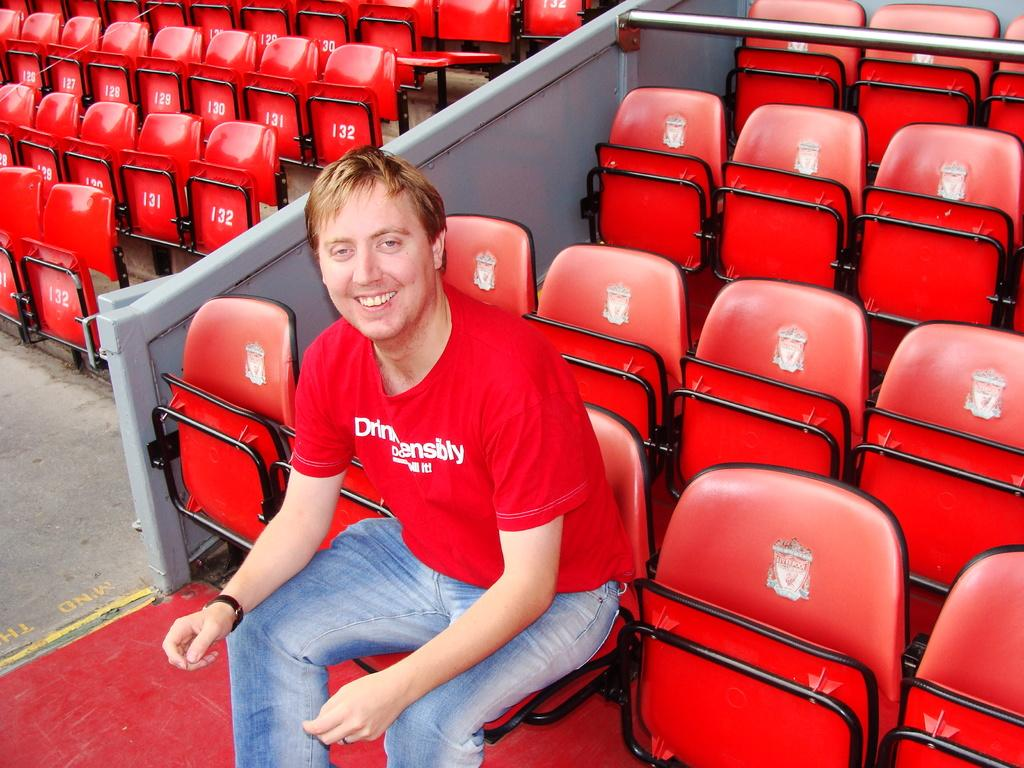Who or what is the main subject in the image? There is a person in the image. What is the person wearing? The person is wearing a red shirt. What is the person doing in the image? The person is sitting on a chair. How many chairs are visible in the image? There are chairs behind the person. What is between the chairs in the image? There is a wall between the chairs. What type of card is being used by the person in the image? There is no card present in the image; the person is wearing a red shirt and sitting on a chair. 